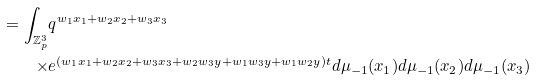<formula> <loc_0><loc_0><loc_500><loc_500>= \int _ { \mathbb { Z } _ { p } ^ { 3 } } & q ^ { w _ { 1 } x _ { 1 } + w _ { 2 } x _ { 2 } + w _ { 3 } x _ { 3 } } \\ \times & e ^ { ( w _ { 1 } x _ { 1 } + w _ { 2 } x _ { 2 } + w _ { 3 } x _ { 3 } + w _ { 2 } w _ { 3 } y + w _ { 1 } w _ { 3 } y + w _ { 1 } w _ { 2 } y ) t } d \mu _ { - 1 } ( x _ { 1 } ) d \mu _ { - 1 } ( x _ { 2 } ) d \mu _ { - 1 } ( x _ { 3 } )</formula> 